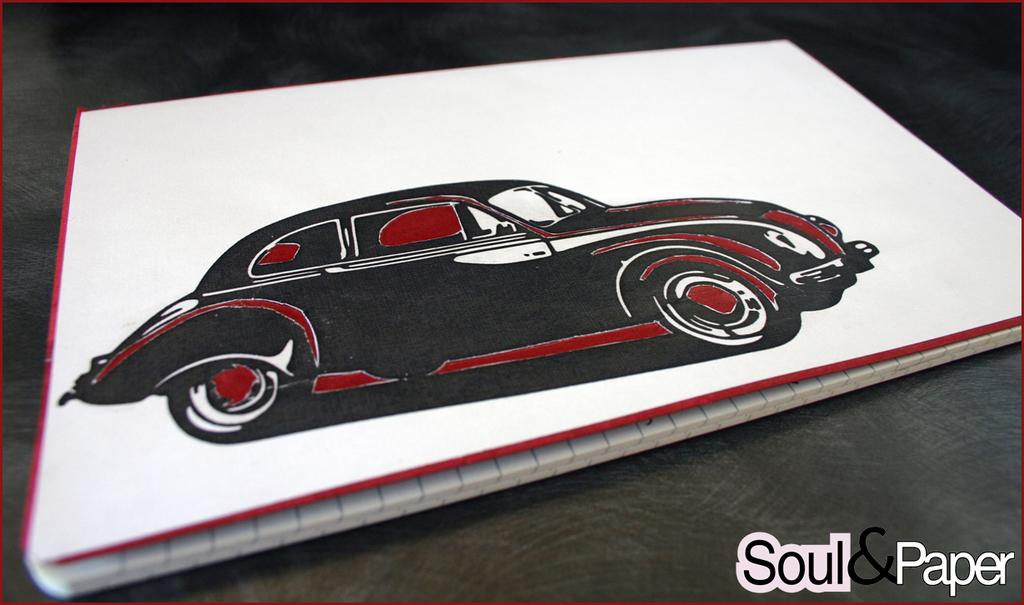What object is visible in the image? There is a book in the image. Where is the book located? The book is on a platform. What is depicted on the book? There is a picture of a car on the book. What additional information can be found at the bottom of the image? There is text written at the bottom of the image. What type of banana is being used as a club in the image? There is no banana or club present in the image. What sense is being stimulated by the image? The image does not stimulate any specific sense; it is a visual representation. 